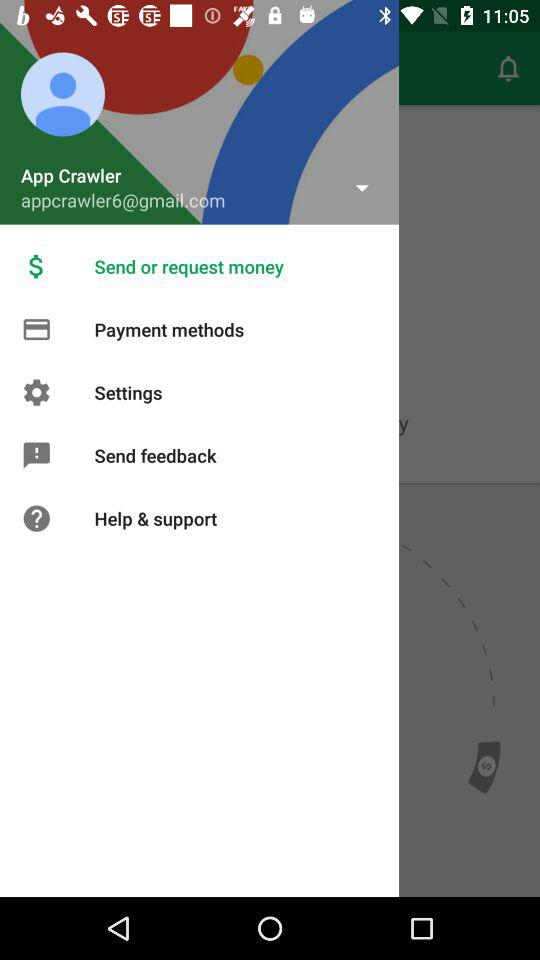What is the email address? The email address is appcrawler6@gmail.com. 